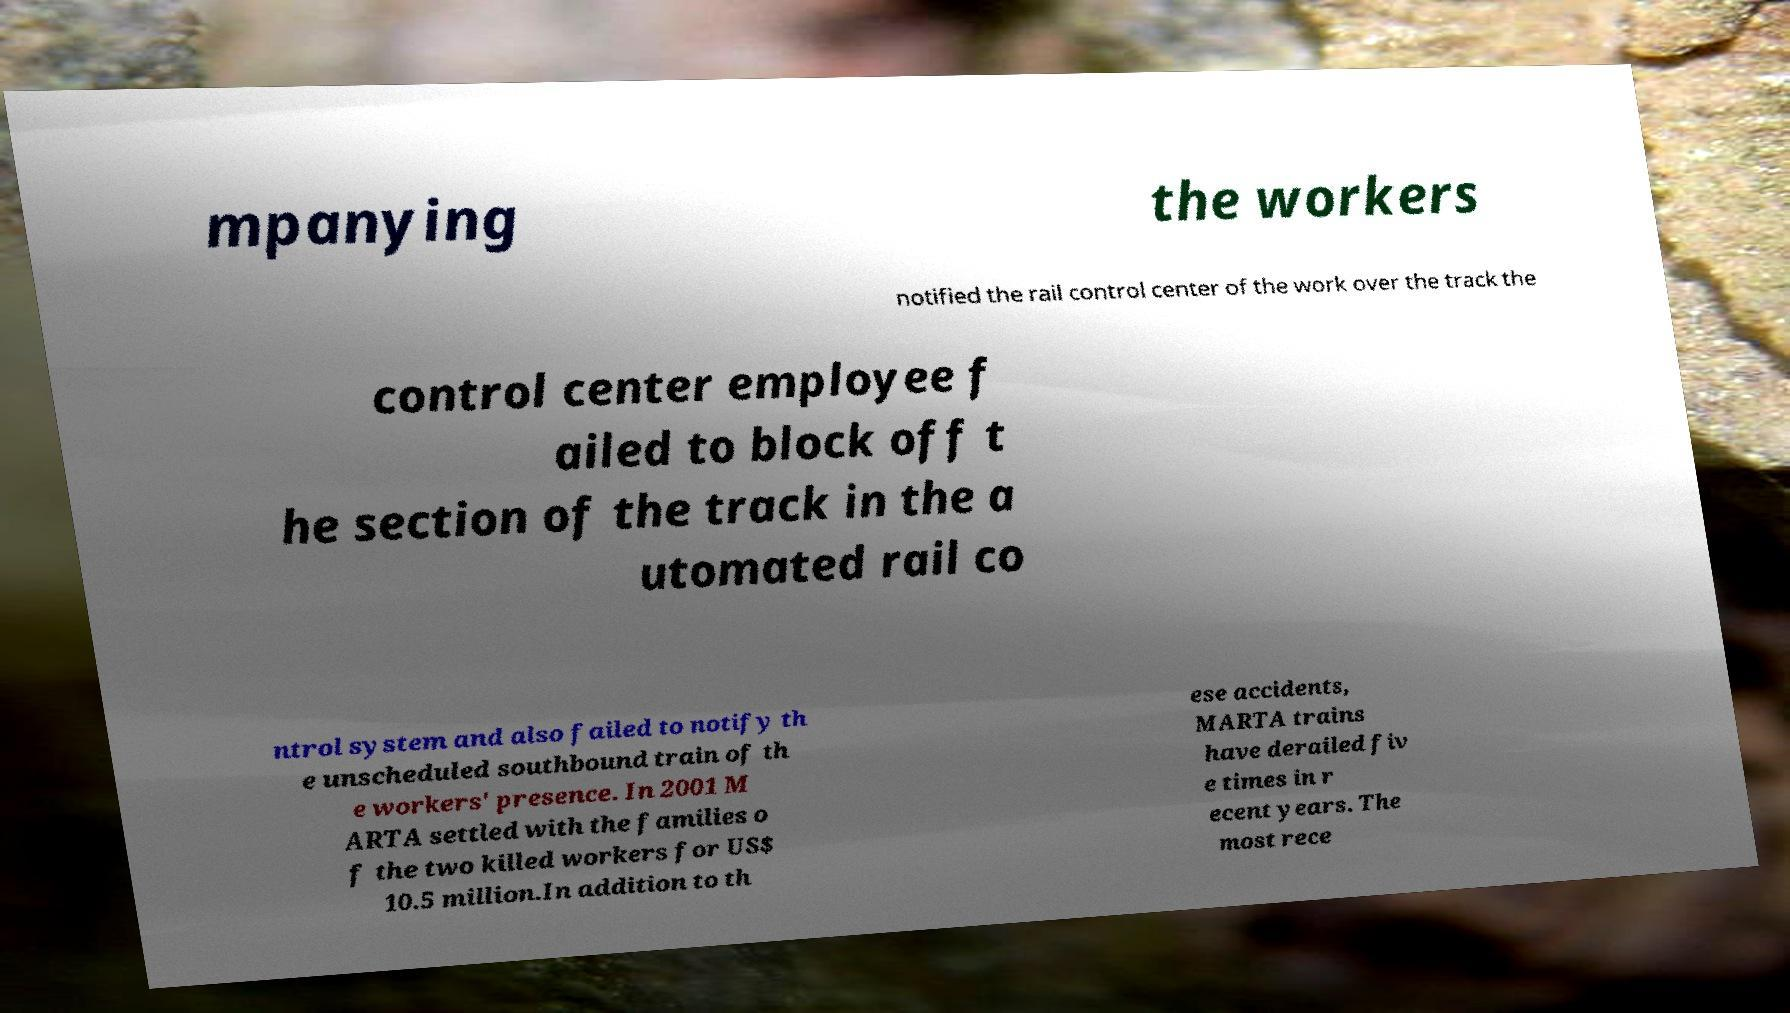There's text embedded in this image that I need extracted. Can you transcribe it verbatim? mpanying the workers notified the rail control center of the work over the track the control center employee f ailed to block off t he section of the track in the a utomated rail co ntrol system and also failed to notify th e unscheduled southbound train of th e workers' presence. In 2001 M ARTA settled with the families o f the two killed workers for US$ 10.5 million.In addition to th ese accidents, MARTA trains have derailed fiv e times in r ecent years. The most rece 